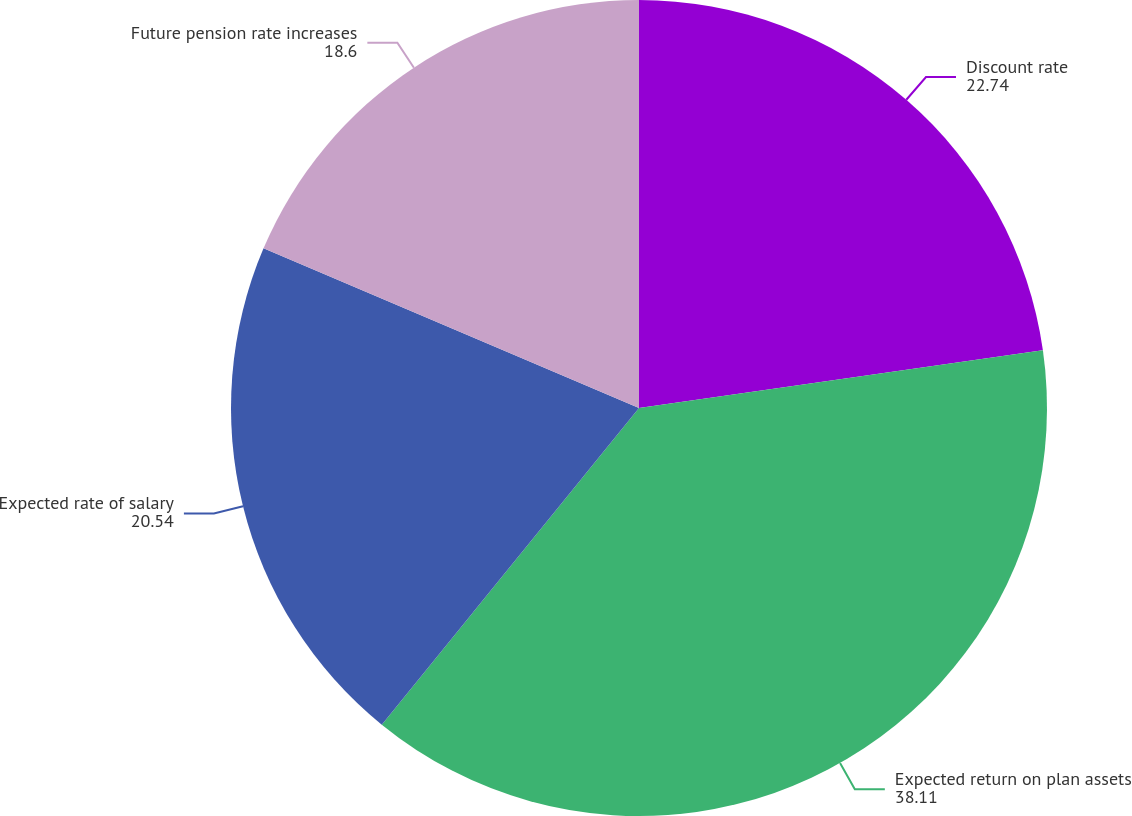Convert chart to OTSL. <chart><loc_0><loc_0><loc_500><loc_500><pie_chart><fcel>Discount rate<fcel>Expected return on plan assets<fcel>Expected rate of salary<fcel>Future pension rate increases<nl><fcel>22.74%<fcel>38.11%<fcel>20.54%<fcel>18.6%<nl></chart> 